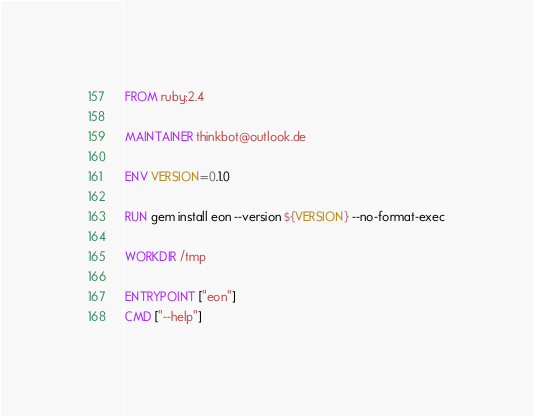<code> <loc_0><loc_0><loc_500><loc_500><_Dockerfile_>FROM ruby:2.4

MAINTAINER thinkbot@outlook.de

ENV VERSION=0.1.0

RUN gem install eon --version ${VERSION} --no-format-exec

WORKDIR /tmp

ENTRYPOINT ["eon"]
CMD ["--help"]
</code> 